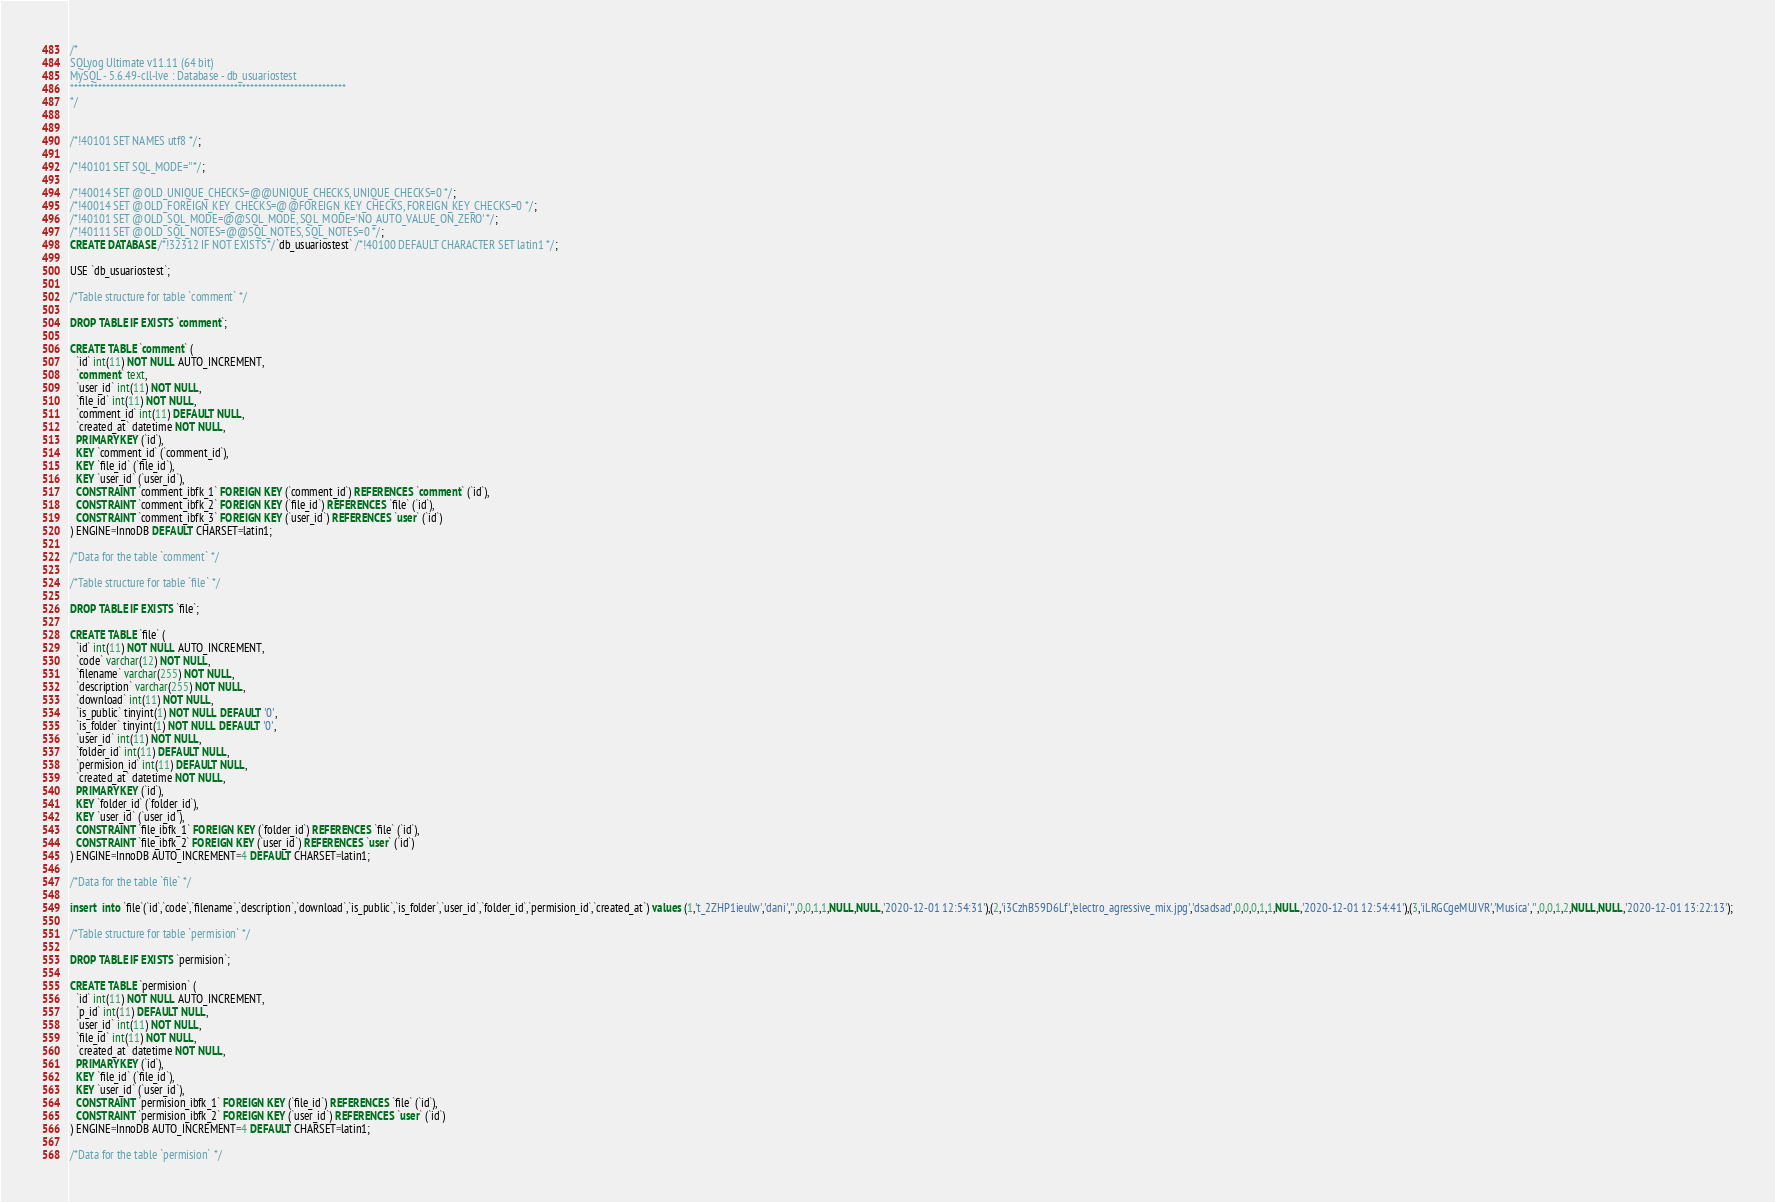<code> <loc_0><loc_0><loc_500><loc_500><_SQL_>/*
SQLyog Ultimate v11.11 (64 bit)
MySQL - 5.6.49-cll-lve : Database - db_usuariostest
*********************************************************************
*/

/*!40101 SET NAMES utf8 */;

/*!40101 SET SQL_MODE=''*/;

/*!40014 SET @OLD_UNIQUE_CHECKS=@@UNIQUE_CHECKS, UNIQUE_CHECKS=0 */;
/*!40014 SET @OLD_FOREIGN_KEY_CHECKS=@@FOREIGN_KEY_CHECKS, FOREIGN_KEY_CHECKS=0 */;
/*!40101 SET @OLD_SQL_MODE=@@SQL_MODE, SQL_MODE='NO_AUTO_VALUE_ON_ZERO' */;
/*!40111 SET @OLD_SQL_NOTES=@@SQL_NOTES, SQL_NOTES=0 */;
CREATE DATABASE /*!32312 IF NOT EXISTS*/`db_usuariostest` /*!40100 DEFAULT CHARACTER SET latin1 */;

USE `db_usuariostest`;

/*Table structure for table `comment` */

DROP TABLE IF EXISTS `comment`;

CREATE TABLE `comment` (
  `id` int(11) NOT NULL AUTO_INCREMENT,
  `comment` text,
  `user_id` int(11) NOT NULL,
  `file_id` int(11) NOT NULL,
  `comment_id` int(11) DEFAULT NULL,
  `created_at` datetime NOT NULL,
  PRIMARY KEY (`id`),
  KEY `comment_id` (`comment_id`),
  KEY `file_id` (`file_id`),
  KEY `user_id` (`user_id`),
  CONSTRAINT `comment_ibfk_1` FOREIGN KEY (`comment_id`) REFERENCES `comment` (`id`),
  CONSTRAINT `comment_ibfk_2` FOREIGN KEY (`file_id`) REFERENCES `file` (`id`),
  CONSTRAINT `comment_ibfk_3` FOREIGN KEY (`user_id`) REFERENCES `user` (`id`)
) ENGINE=InnoDB DEFAULT CHARSET=latin1;

/*Data for the table `comment` */

/*Table structure for table `file` */

DROP TABLE IF EXISTS `file`;

CREATE TABLE `file` (
  `id` int(11) NOT NULL AUTO_INCREMENT,
  `code` varchar(12) NOT NULL,
  `filename` varchar(255) NOT NULL,
  `description` varchar(255) NOT NULL,
  `download` int(11) NOT NULL,
  `is_public` tinyint(1) NOT NULL DEFAULT '0',
  `is_folder` tinyint(1) NOT NULL DEFAULT '0',
  `user_id` int(11) NOT NULL,
  `folder_id` int(11) DEFAULT NULL,
  `permision_id` int(11) DEFAULT NULL,
  `created_at` datetime NOT NULL,
  PRIMARY KEY (`id`),
  KEY `folder_id` (`folder_id`),
  KEY `user_id` (`user_id`),
  CONSTRAINT `file_ibfk_1` FOREIGN KEY (`folder_id`) REFERENCES `file` (`id`),
  CONSTRAINT `file_ibfk_2` FOREIGN KEY (`user_id`) REFERENCES `user` (`id`)
) ENGINE=InnoDB AUTO_INCREMENT=4 DEFAULT CHARSET=latin1;

/*Data for the table `file` */

insert  into `file`(`id`,`code`,`filename`,`description`,`download`,`is_public`,`is_folder`,`user_id`,`folder_id`,`permision_id`,`created_at`) values (1,'t_2ZHP1ieulw','dani','',0,0,1,1,NULL,NULL,'2020-12-01 12:54:31'),(2,'i3CzhB59D6Lf','electro_agressive_mix.jpg','dsadsad',0,0,0,1,1,NULL,'2020-12-01 12:54:41'),(3,'iLRGCgeMUJVR','Musica','',0,0,1,2,NULL,NULL,'2020-12-01 13:22:13');

/*Table structure for table `permision` */

DROP TABLE IF EXISTS `permision`;

CREATE TABLE `permision` (
  `id` int(11) NOT NULL AUTO_INCREMENT,
  `p_id` int(11) DEFAULT NULL,
  `user_id` int(11) NOT NULL,
  `file_id` int(11) NOT NULL,
  `created_at` datetime NOT NULL,
  PRIMARY KEY (`id`),
  KEY `file_id` (`file_id`),
  KEY `user_id` (`user_id`),
  CONSTRAINT `permision_ibfk_1` FOREIGN KEY (`file_id`) REFERENCES `file` (`id`),
  CONSTRAINT `permision_ibfk_2` FOREIGN KEY (`user_id`) REFERENCES `user` (`id`)
) ENGINE=InnoDB AUTO_INCREMENT=4 DEFAULT CHARSET=latin1;

/*Data for the table `permision` */
</code> 